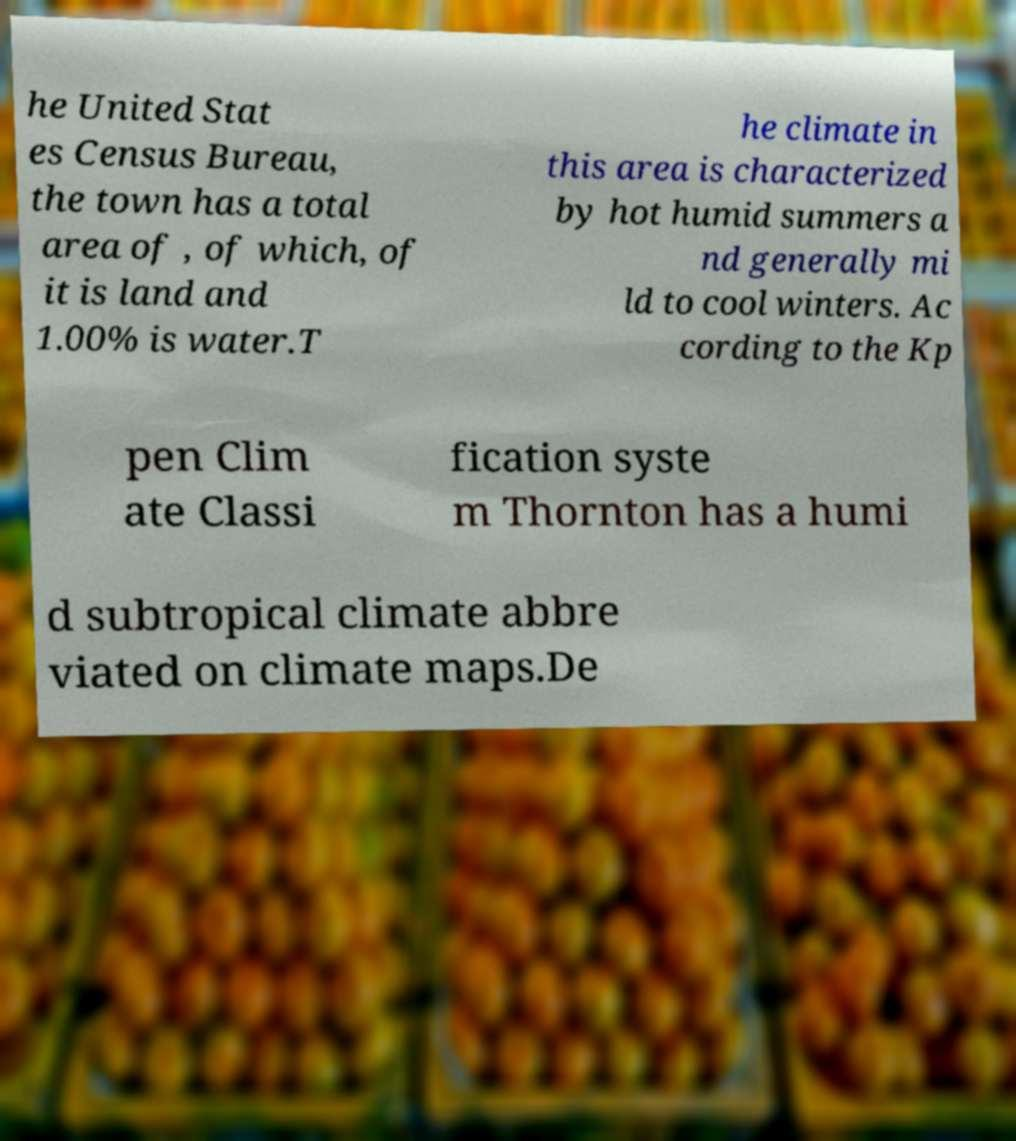Please read and relay the text visible in this image. What does it say? he United Stat es Census Bureau, the town has a total area of , of which, of it is land and 1.00% is water.T he climate in this area is characterized by hot humid summers a nd generally mi ld to cool winters. Ac cording to the Kp pen Clim ate Classi fication syste m Thornton has a humi d subtropical climate abbre viated on climate maps.De 